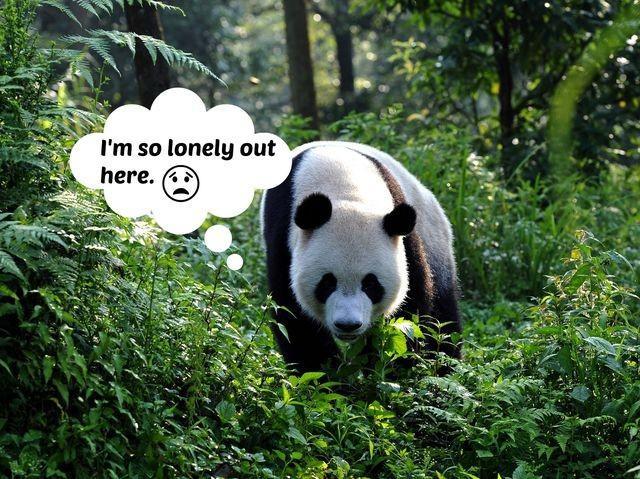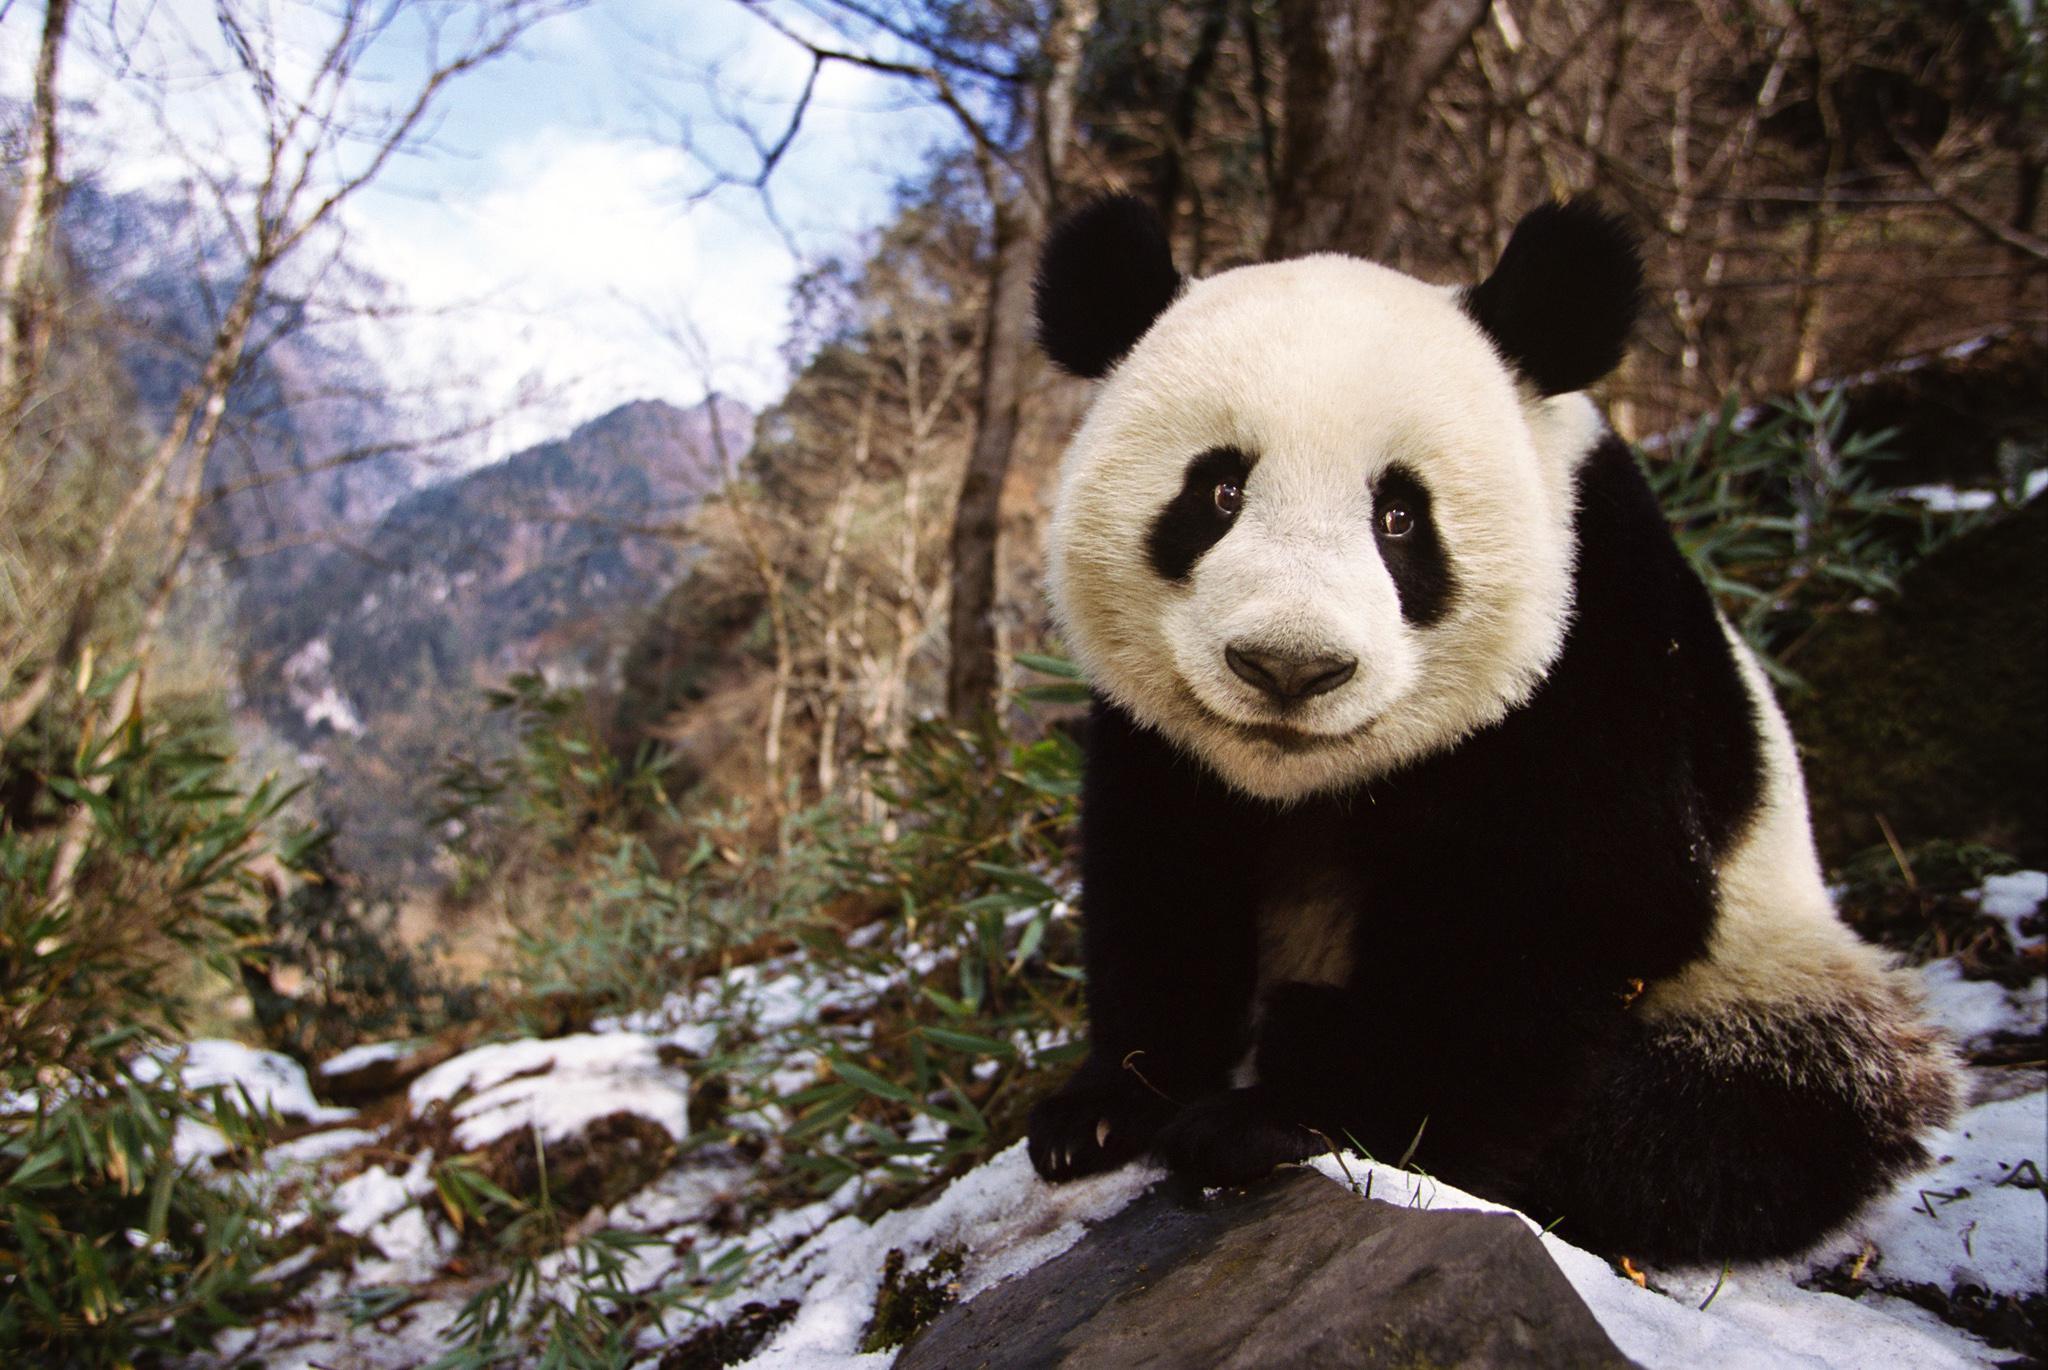The first image is the image on the left, the second image is the image on the right. For the images shown, is this caption "The right image shows one panda, which is posed with open mouth to munch on a green stem." true? Answer yes or no. No. The first image is the image on the left, the second image is the image on the right. Analyze the images presented: Is the assertion "An image contains at lest four pandas." valid? Answer yes or no. No. 